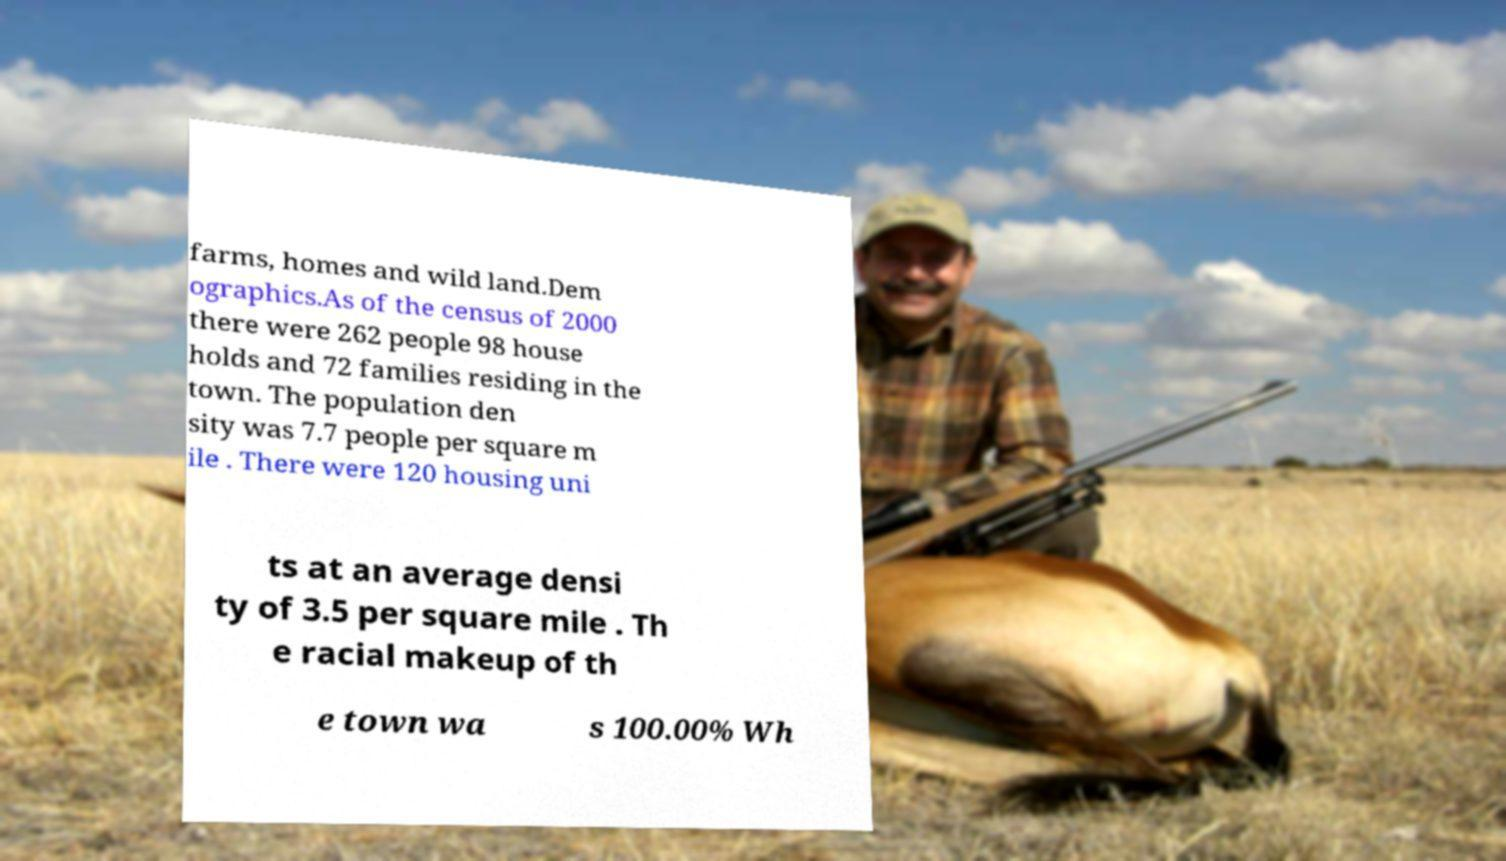There's text embedded in this image that I need extracted. Can you transcribe it verbatim? farms, homes and wild land.Dem ographics.As of the census of 2000 there were 262 people 98 house holds and 72 families residing in the town. The population den sity was 7.7 people per square m ile . There were 120 housing uni ts at an average densi ty of 3.5 per square mile . Th e racial makeup of th e town wa s 100.00% Wh 